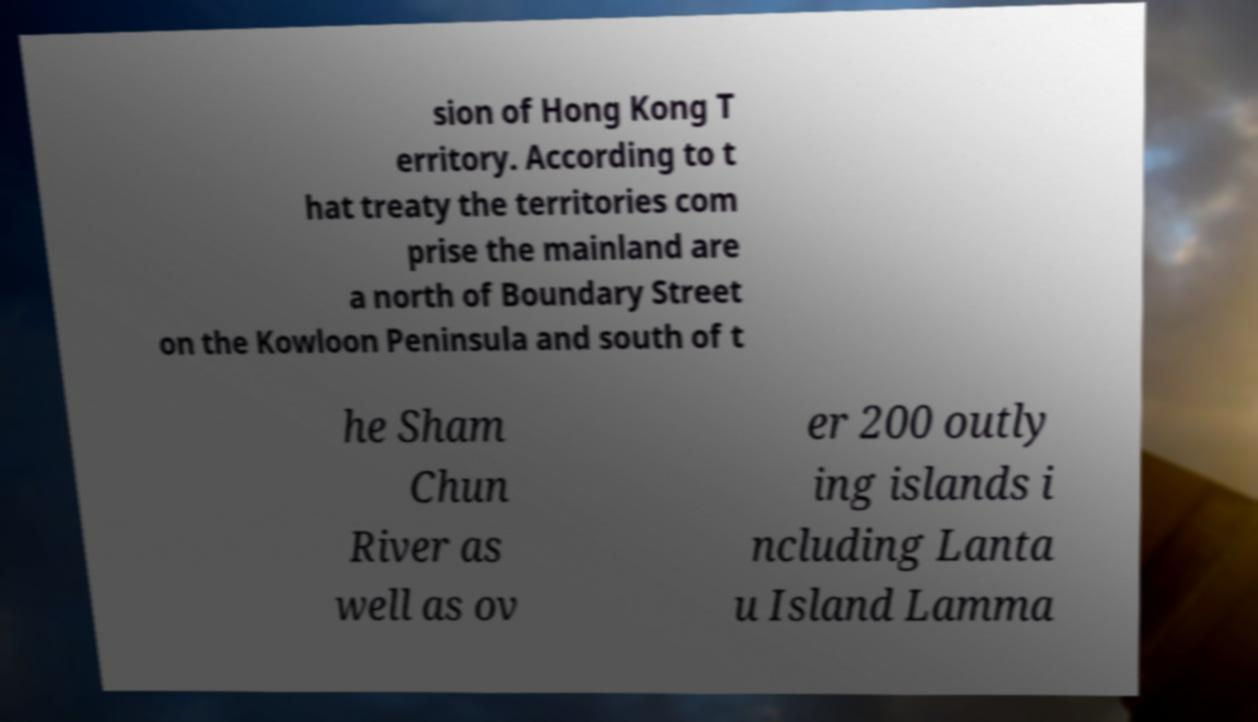Can you accurately transcribe the text from the provided image for me? sion of Hong Kong T erritory. According to t hat treaty the territories com prise the mainland are a north of Boundary Street on the Kowloon Peninsula and south of t he Sham Chun River as well as ov er 200 outly ing islands i ncluding Lanta u Island Lamma 